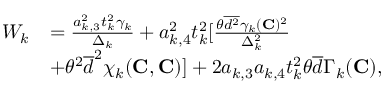Convert formula to latex. <formula><loc_0><loc_0><loc_500><loc_500>\begin{array} { r l } { W _ { k } } & { = \frac { a _ { k , 3 } ^ { 2 } t _ { k } ^ { 2 } \gamma _ { k } } { \Delta _ { k } } + a _ { k , 4 } ^ { 2 } t _ { k } ^ { 2 } [ \frac { \theta \overline { { d ^ { 2 } } } \gamma _ { k } ( { C } ) ^ { 2 } } { \Delta _ { k } ^ { 2 } } } \\ & { + \theta ^ { 2 } \overline { d } ^ { 2 } \chi _ { k } ( { C } , { C } ) ] + 2 a _ { k , 3 } a _ { k , 4 } t _ { k } ^ { 2 } \theta \overline { d } \Gamma _ { k } ( { C } ) , } \end{array}</formula> 